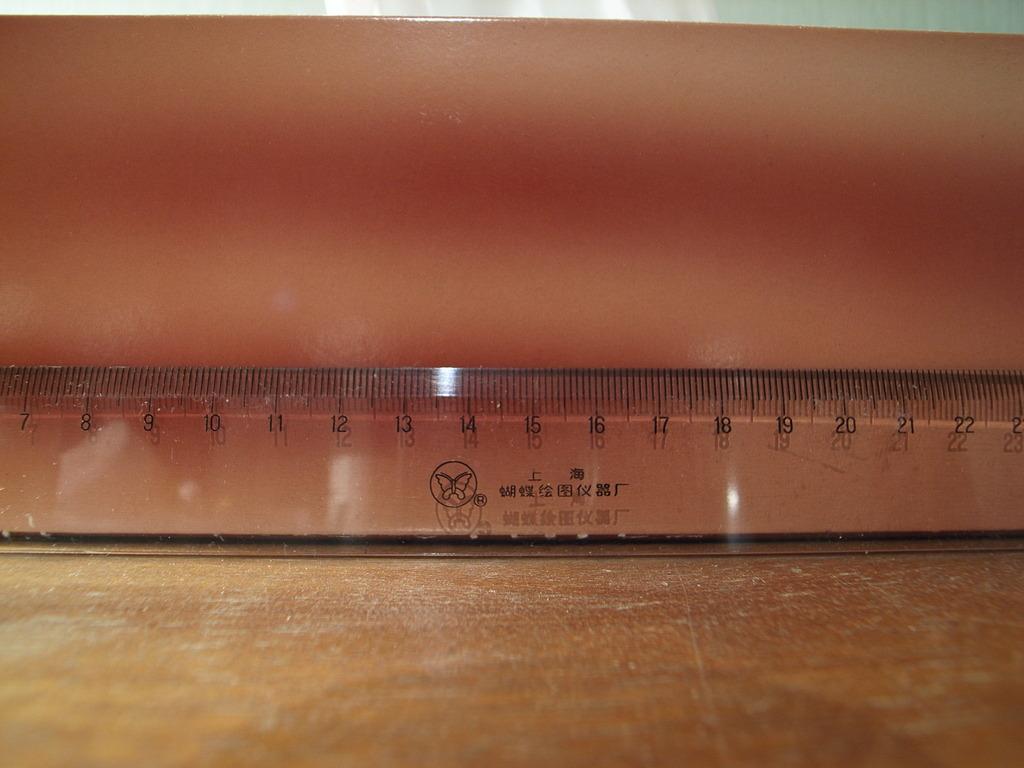What is the highest number visible on the ruler?
Your answer should be very brief. 22. What is the lowest number visable?
Make the answer very short. 7. 